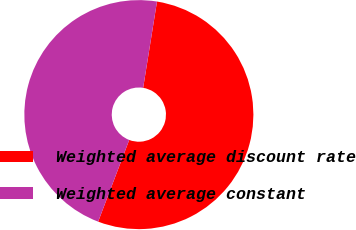Convert chart to OTSL. <chart><loc_0><loc_0><loc_500><loc_500><pie_chart><fcel>Weighted average discount rate<fcel>Weighted average constant<nl><fcel>53.25%<fcel>46.75%<nl></chart> 